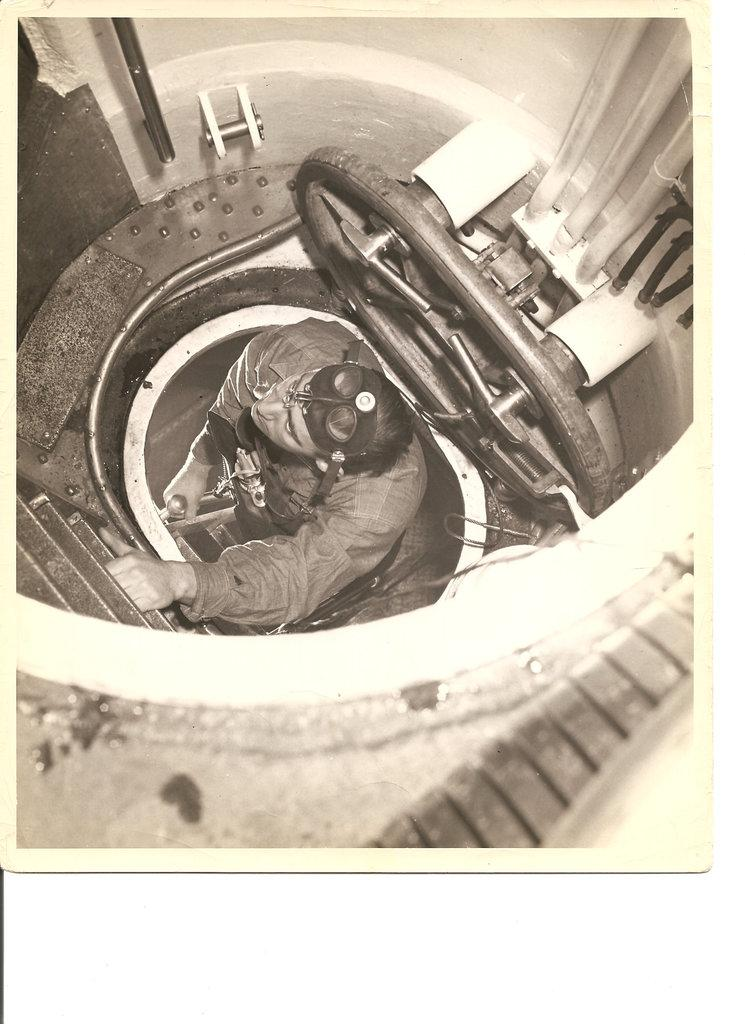What is the main subject of the image? The main subject of the image is a person. What is the person in the image doing? The person is climbing a ladder. What other object can be seen in the image? There is an object in the image that looks like a tunnel. Can you see a hen laying food near the person's ear in the image? There is no hen or food near the person's ear in the image. 